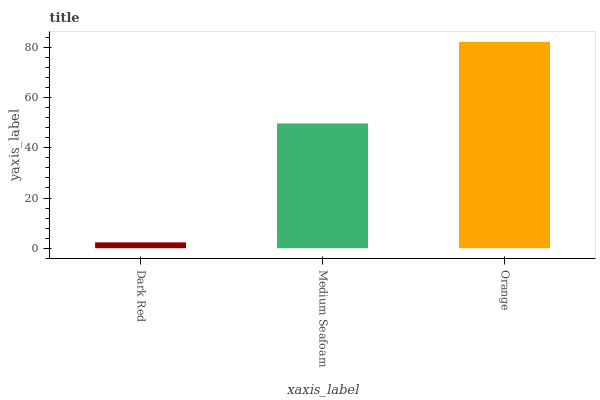Is Medium Seafoam the minimum?
Answer yes or no. No. Is Medium Seafoam the maximum?
Answer yes or no. No. Is Medium Seafoam greater than Dark Red?
Answer yes or no. Yes. Is Dark Red less than Medium Seafoam?
Answer yes or no. Yes. Is Dark Red greater than Medium Seafoam?
Answer yes or no. No. Is Medium Seafoam less than Dark Red?
Answer yes or no. No. Is Medium Seafoam the high median?
Answer yes or no. Yes. Is Medium Seafoam the low median?
Answer yes or no. Yes. Is Dark Red the high median?
Answer yes or no. No. Is Dark Red the low median?
Answer yes or no. No. 